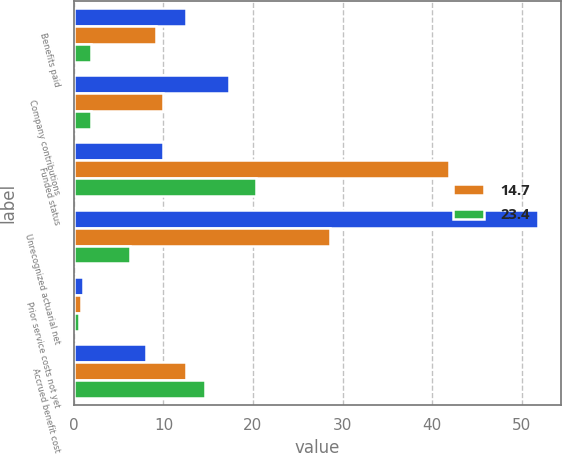Convert chart. <chart><loc_0><loc_0><loc_500><loc_500><stacked_bar_chart><ecel><fcel>Benefits paid<fcel>Company contributions<fcel>Funded status<fcel>Unrecognized actuarial net<fcel>Prior service costs not yet<fcel>Accrued benefit cost<nl><fcel>nan<fcel>12.5<fcel>17.3<fcel>9.9<fcel>51.8<fcel>1<fcel>8.1<nl><fcel>14.7<fcel>9.2<fcel>9.9<fcel>41.9<fcel>28.6<fcel>0.8<fcel>12.5<nl><fcel>23.4<fcel>1.9<fcel>1.9<fcel>20.3<fcel>6.3<fcel>0.6<fcel>14.6<nl></chart> 